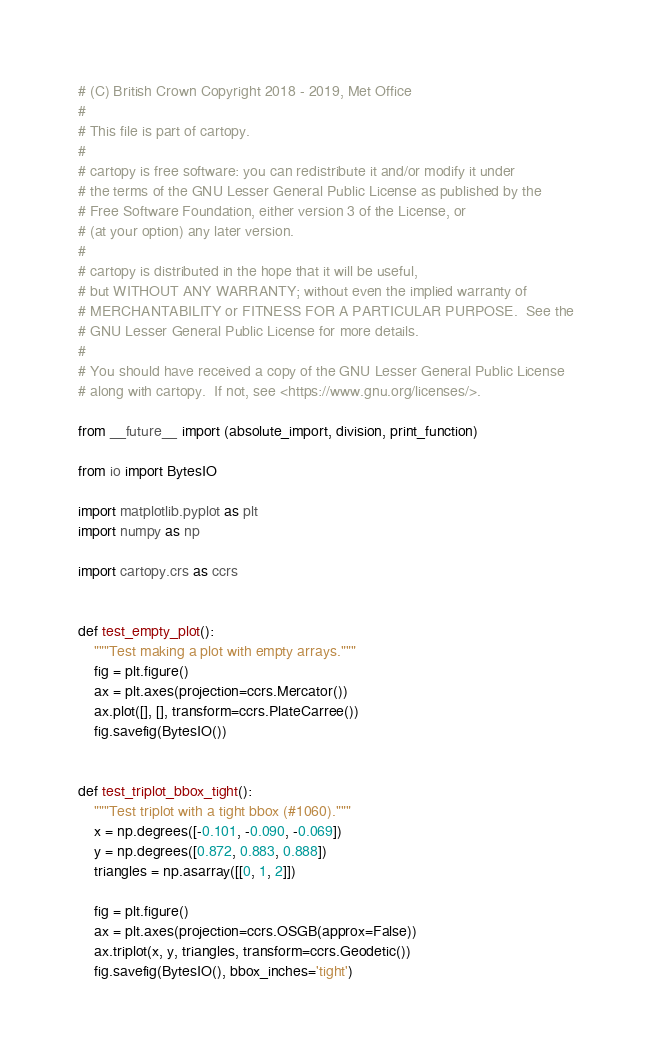<code> <loc_0><loc_0><loc_500><loc_500><_Python_># (C) British Crown Copyright 2018 - 2019, Met Office
#
# This file is part of cartopy.
#
# cartopy is free software: you can redistribute it and/or modify it under
# the terms of the GNU Lesser General Public License as published by the
# Free Software Foundation, either version 3 of the License, or
# (at your option) any later version.
#
# cartopy is distributed in the hope that it will be useful,
# but WITHOUT ANY WARRANTY; without even the implied warranty of
# MERCHANTABILITY or FITNESS FOR A PARTICULAR PURPOSE.  See the
# GNU Lesser General Public License for more details.
#
# You should have received a copy of the GNU Lesser General Public License
# along with cartopy.  If not, see <https://www.gnu.org/licenses/>.

from __future__ import (absolute_import, division, print_function)

from io import BytesIO

import matplotlib.pyplot as plt
import numpy as np

import cartopy.crs as ccrs


def test_empty_plot():
    """Test making a plot with empty arrays."""
    fig = plt.figure()
    ax = plt.axes(projection=ccrs.Mercator())
    ax.plot([], [], transform=ccrs.PlateCarree())
    fig.savefig(BytesIO())


def test_triplot_bbox_tight():
    """Test triplot with a tight bbox (#1060)."""
    x = np.degrees([-0.101, -0.090, -0.069])
    y = np.degrees([0.872, 0.883, 0.888])
    triangles = np.asarray([[0, 1, 2]])

    fig = plt.figure()
    ax = plt.axes(projection=ccrs.OSGB(approx=False))
    ax.triplot(x, y, triangles, transform=ccrs.Geodetic())
    fig.savefig(BytesIO(), bbox_inches='tight')
</code> 